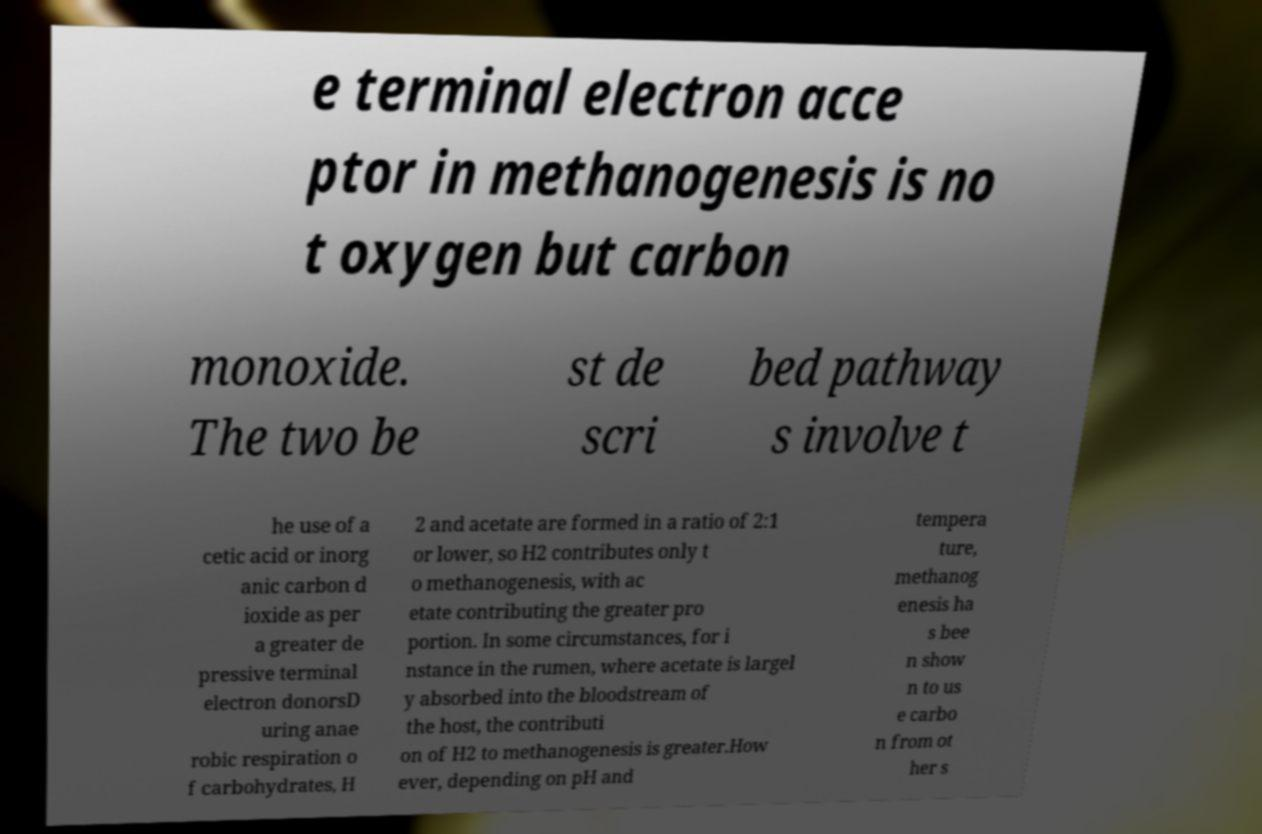Can you read and provide the text displayed in the image?This photo seems to have some interesting text. Can you extract and type it out for me? e terminal electron acce ptor in methanogenesis is no t oxygen but carbon monoxide. The two be st de scri bed pathway s involve t he use of a cetic acid or inorg anic carbon d ioxide as per a greater de pressive terminal electron donorsD uring anae robic respiration o f carbohydrates, H 2 and acetate are formed in a ratio of 2:1 or lower, so H2 contributes only t o methanogenesis, with ac etate contributing the greater pro portion. In some circumstances, for i nstance in the rumen, where acetate is largel y absorbed into the bloodstream of the host, the contributi on of H2 to methanogenesis is greater.How ever, depending on pH and tempera ture, methanog enesis ha s bee n show n to us e carbo n from ot her s 